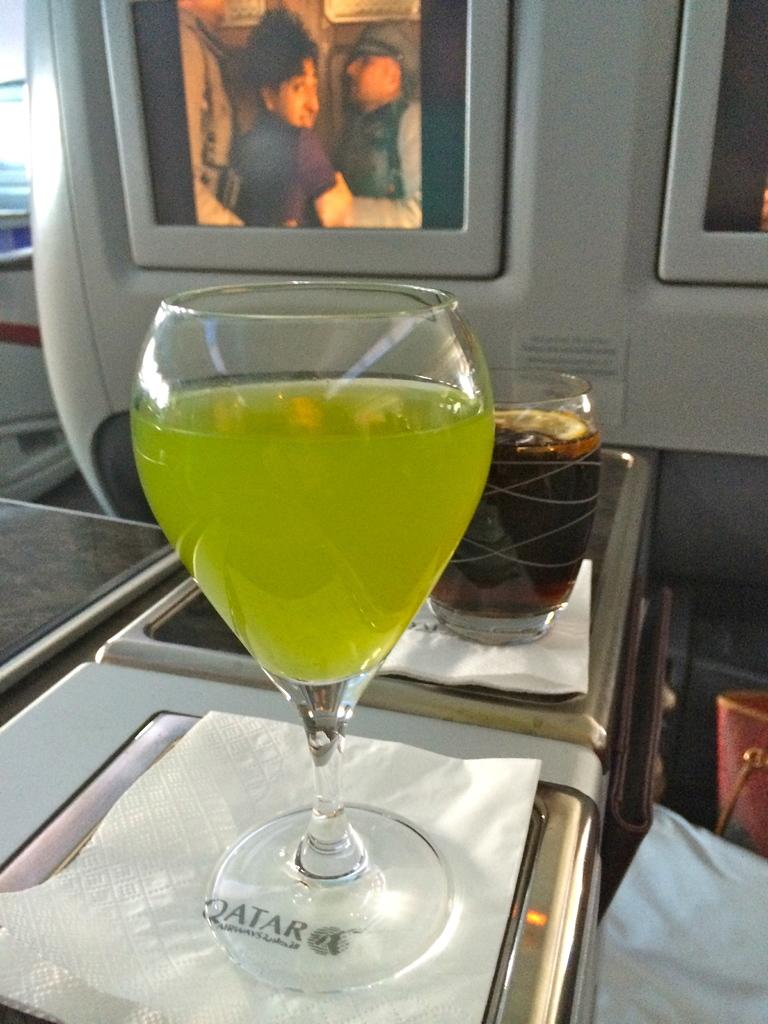What is in the glasses that are visible in the image? There are glasses with liquids in the image. What are the glasses placed on? The glasses are on tissues. What can be seen in the background of the image? There are screens in the background of the image. What is located on the right side of the image? There are objects on the right side of the image. Can you tell me what news is being reported on the receipt in the image? There is no receipt or news present in the image. Is anyone swimming in the image? There is no swimming or pool depicted in the image. 